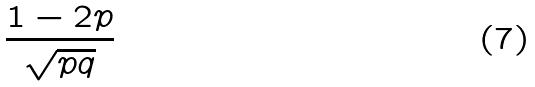Convert formula to latex. <formula><loc_0><loc_0><loc_500><loc_500>\frac { 1 - 2 p } { \sqrt { p q } }</formula> 